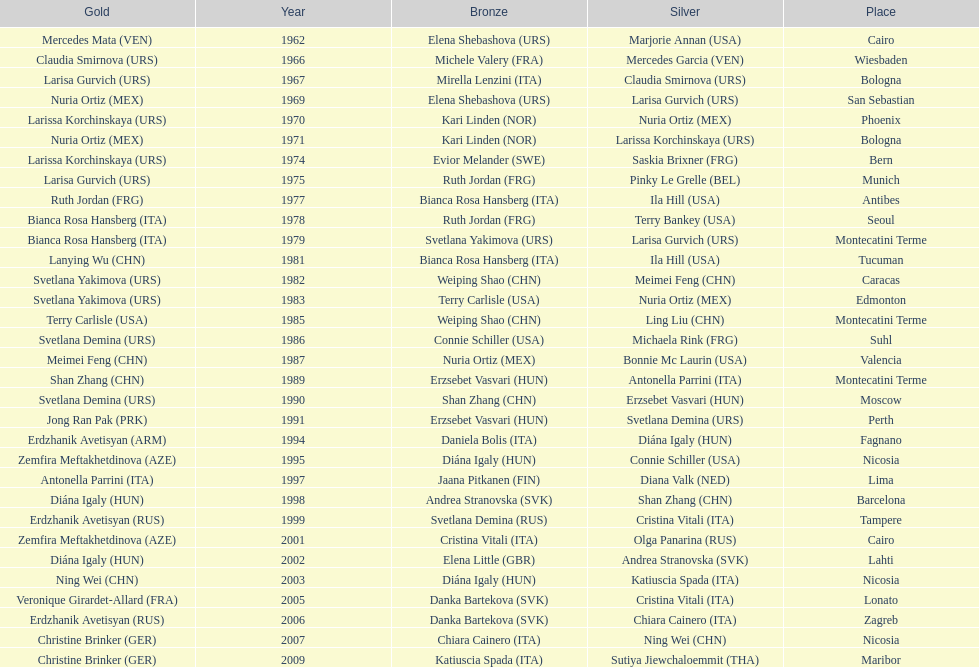Could you help me parse every detail presented in this table? {'header': ['Gold', 'Year', 'Bronze', 'Silver', 'Place'], 'rows': [['Mercedes Mata\xa0(VEN)', '1962', 'Elena Shebashova\xa0(URS)', 'Marjorie Annan\xa0(USA)', 'Cairo'], ['Claudia Smirnova\xa0(URS)', '1966', 'Michele Valery\xa0(FRA)', 'Mercedes Garcia\xa0(VEN)', 'Wiesbaden'], ['Larisa Gurvich\xa0(URS)', '1967', 'Mirella Lenzini\xa0(ITA)', 'Claudia Smirnova\xa0(URS)', 'Bologna'], ['Nuria Ortiz\xa0(MEX)', '1969', 'Elena Shebashova\xa0(URS)', 'Larisa Gurvich\xa0(URS)', 'San Sebastian'], ['Larissa Korchinskaya\xa0(URS)', '1970', 'Kari Linden\xa0(NOR)', 'Nuria Ortiz\xa0(MEX)', 'Phoenix'], ['Nuria Ortiz\xa0(MEX)', '1971', 'Kari Linden\xa0(NOR)', 'Larissa Korchinskaya\xa0(URS)', 'Bologna'], ['Larissa Korchinskaya\xa0(URS)', '1974', 'Evior Melander\xa0(SWE)', 'Saskia Brixner\xa0(FRG)', 'Bern'], ['Larisa Gurvich\xa0(URS)', '1975', 'Ruth Jordan\xa0(FRG)', 'Pinky Le Grelle\xa0(BEL)', 'Munich'], ['Ruth Jordan\xa0(FRG)', '1977', 'Bianca Rosa Hansberg\xa0(ITA)', 'Ila Hill\xa0(USA)', 'Antibes'], ['Bianca Rosa Hansberg\xa0(ITA)', '1978', 'Ruth Jordan\xa0(FRG)', 'Terry Bankey\xa0(USA)', 'Seoul'], ['Bianca Rosa Hansberg\xa0(ITA)', '1979', 'Svetlana Yakimova\xa0(URS)', 'Larisa Gurvich\xa0(URS)', 'Montecatini Terme'], ['Lanying Wu\xa0(CHN)', '1981', 'Bianca Rosa Hansberg\xa0(ITA)', 'Ila Hill\xa0(USA)', 'Tucuman'], ['Svetlana Yakimova\xa0(URS)', '1982', 'Weiping Shao\xa0(CHN)', 'Meimei Feng\xa0(CHN)', 'Caracas'], ['Svetlana Yakimova\xa0(URS)', '1983', 'Terry Carlisle\xa0(USA)', 'Nuria Ortiz\xa0(MEX)', 'Edmonton'], ['Terry Carlisle\xa0(USA)', '1985', 'Weiping Shao\xa0(CHN)', 'Ling Liu\xa0(CHN)', 'Montecatini Terme'], ['Svetlana Demina\xa0(URS)', '1986', 'Connie Schiller\xa0(USA)', 'Michaela Rink\xa0(FRG)', 'Suhl'], ['Meimei Feng\xa0(CHN)', '1987', 'Nuria Ortiz\xa0(MEX)', 'Bonnie Mc Laurin\xa0(USA)', 'Valencia'], ['Shan Zhang\xa0(CHN)', '1989', 'Erzsebet Vasvari\xa0(HUN)', 'Antonella Parrini\xa0(ITA)', 'Montecatini Terme'], ['Svetlana Demina\xa0(URS)', '1990', 'Shan Zhang\xa0(CHN)', 'Erzsebet Vasvari\xa0(HUN)', 'Moscow'], ['Jong Ran Pak\xa0(PRK)', '1991', 'Erzsebet Vasvari\xa0(HUN)', 'Svetlana Demina\xa0(URS)', 'Perth'], ['Erdzhanik Avetisyan\xa0(ARM)', '1994', 'Daniela Bolis\xa0(ITA)', 'Diána Igaly\xa0(HUN)', 'Fagnano'], ['Zemfira Meftakhetdinova\xa0(AZE)', '1995', 'Diána Igaly\xa0(HUN)', 'Connie Schiller\xa0(USA)', 'Nicosia'], ['Antonella Parrini\xa0(ITA)', '1997', 'Jaana Pitkanen\xa0(FIN)', 'Diana Valk\xa0(NED)', 'Lima'], ['Diána Igaly\xa0(HUN)', '1998', 'Andrea Stranovska\xa0(SVK)', 'Shan Zhang\xa0(CHN)', 'Barcelona'], ['Erdzhanik Avetisyan\xa0(RUS)', '1999', 'Svetlana Demina\xa0(RUS)', 'Cristina Vitali\xa0(ITA)', 'Tampere'], ['Zemfira Meftakhetdinova\xa0(AZE)', '2001', 'Cristina Vitali\xa0(ITA)', 'Olga Panarina\xa0(RUS)', 'Cairo'], ['Diána Igaly\xa0(HUN)', '2002', 'Elena Little\xa0(GBR)', 'Andrea Stranovska\xa0(SVK)', 'Lahti'], ['Ning Wei\xa0(CHN)', '2003', 'Diána Igaly\xa0(HUN)', 'Katiuscia Spada\xa0(ITA)', 'Nicosia'], ['Veronique Girardet-Allard\xa0(FRA)', '2005', 'Danka Bartekova\xa0(SVK)', 'Cristina Vitali\xa0(ITA)', 'Lonato'], ['Erdzhanik Avetisyan\xa0(RUS)', '2006', 'Danka Bartekova\xa0(SVK)', 'Chiara Cainero\xa0(ITA)', 'Zagreb'], ['Christine Brinker\xa0(GER)', '2007', 'Chiara Cainero\xa0(ITA)', 'Ning Wei\xa0(CHN)', 'Nicosia'], ['Christine Brinker\xa0(GER)', '2009', 'Katiuscia Spada\xa0(ITA)', 'Sutiya Jiewchaloemmit\xa0(THA)', 'Maribor']]} Has china or mexico garnered more gold medals in their history? China. 